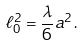<formula> <loc_0><loc_0><loc_500><loc_500>\ell _ { 0 } ^ { 2 } = \frac { \lambda } { 6 } a ^ { 2 } \, .</formula> 